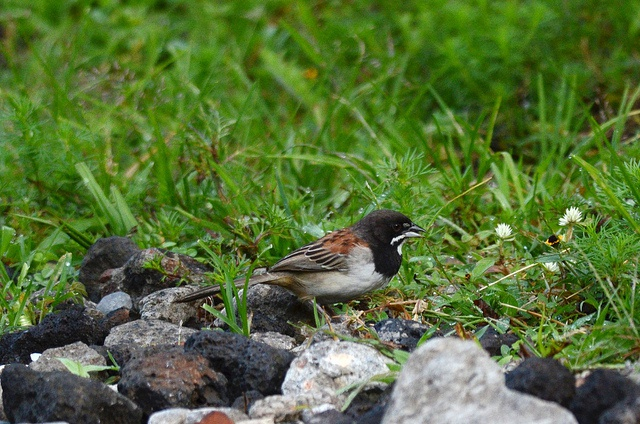Describe the objects in this image and their specific colors. I can see a bird in darkgreen, black, gray, and darkgray tones in this image. 